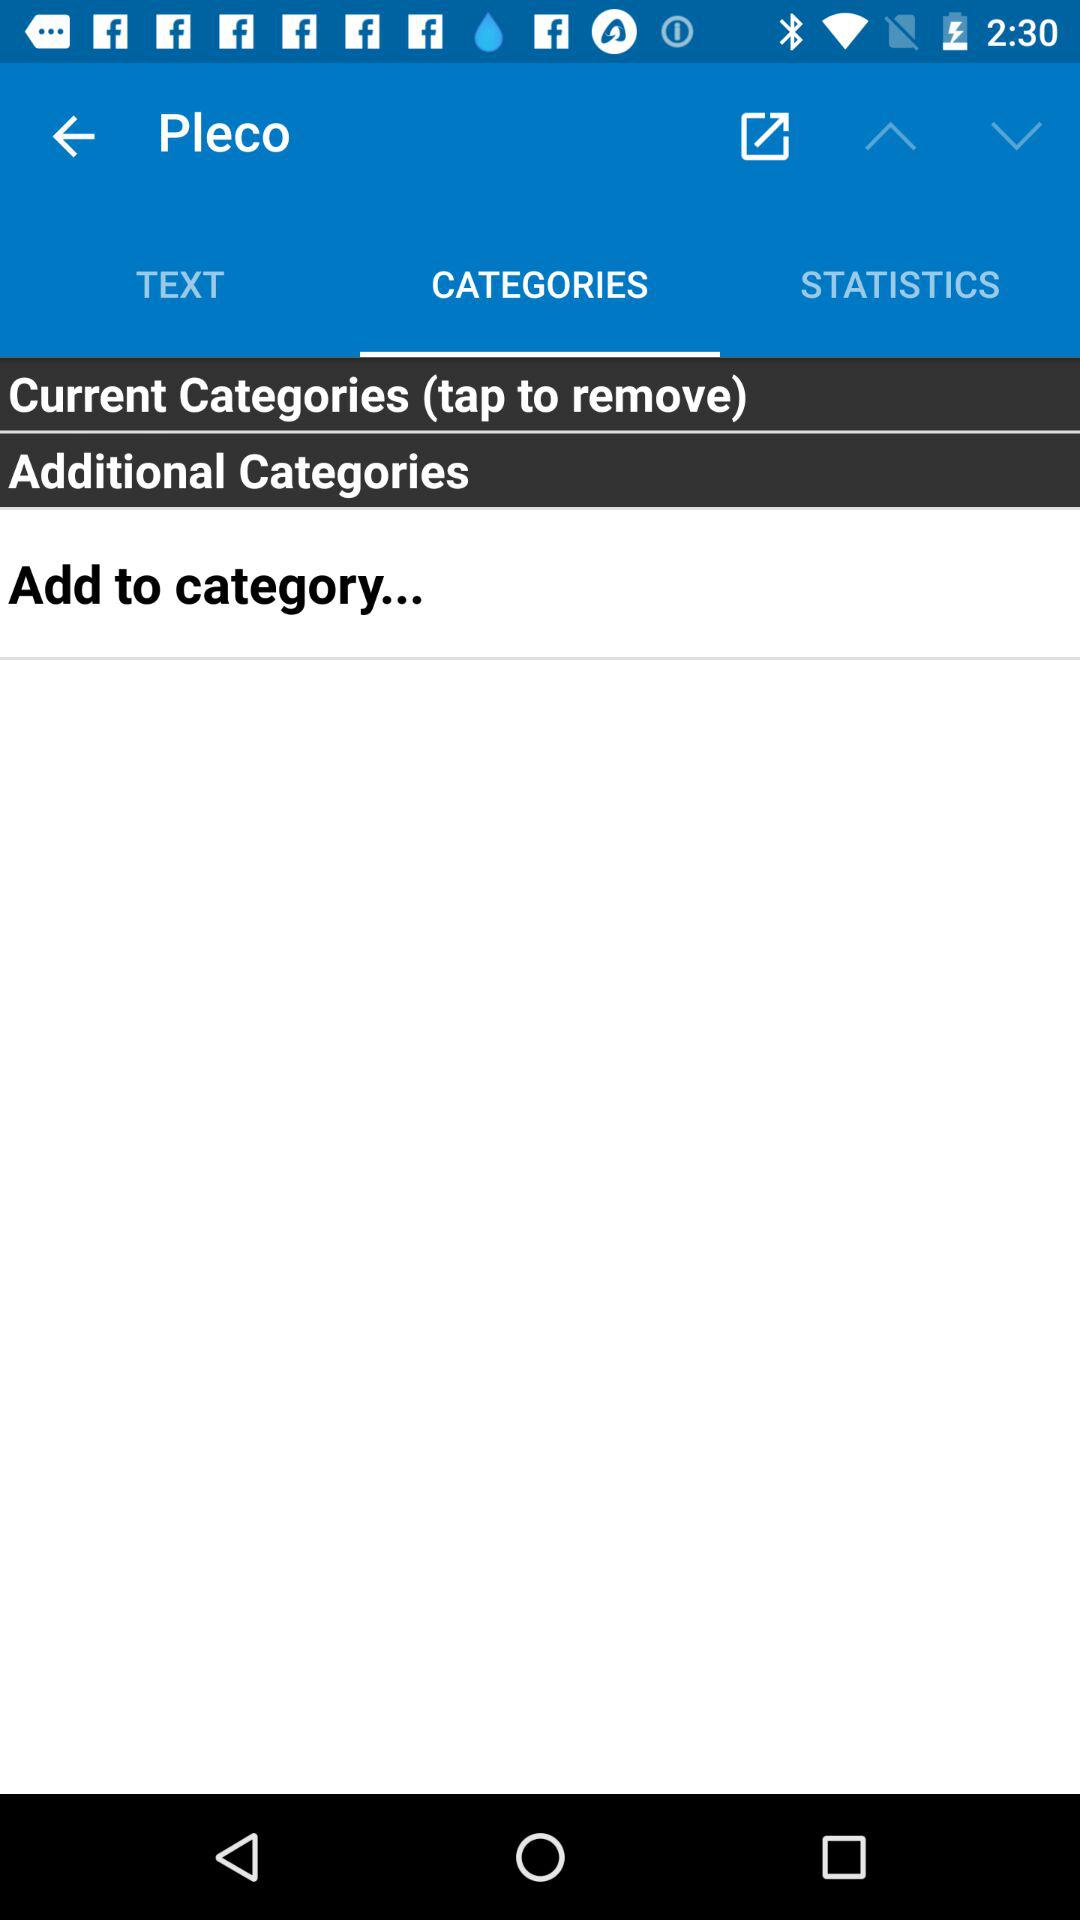Which version of the application is being used?
When the provided information is insufficient, respond with <no answer>. <no answer> 